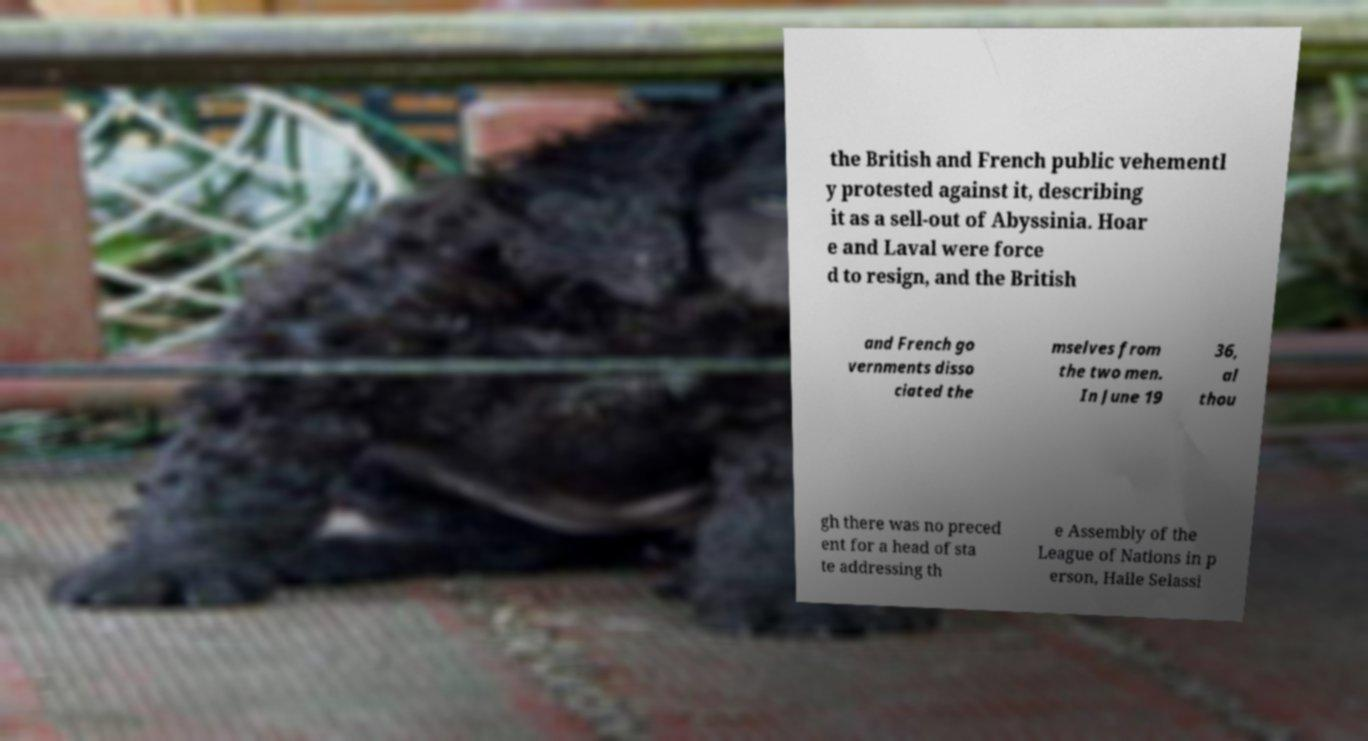Please identify and transcribe the text found in this image. the British and French public vehementl y protested against it, describing it as a sell-out of Abyssinia. Hoar e and Laval were force d to resign, and the British and French go vernments disso ciated the mselves from the two men. In June 19 36, al thou gh there was no preced ent for a head of sta te addressing th e Assembly of the League of Nations in p erson, Haile Selassi 